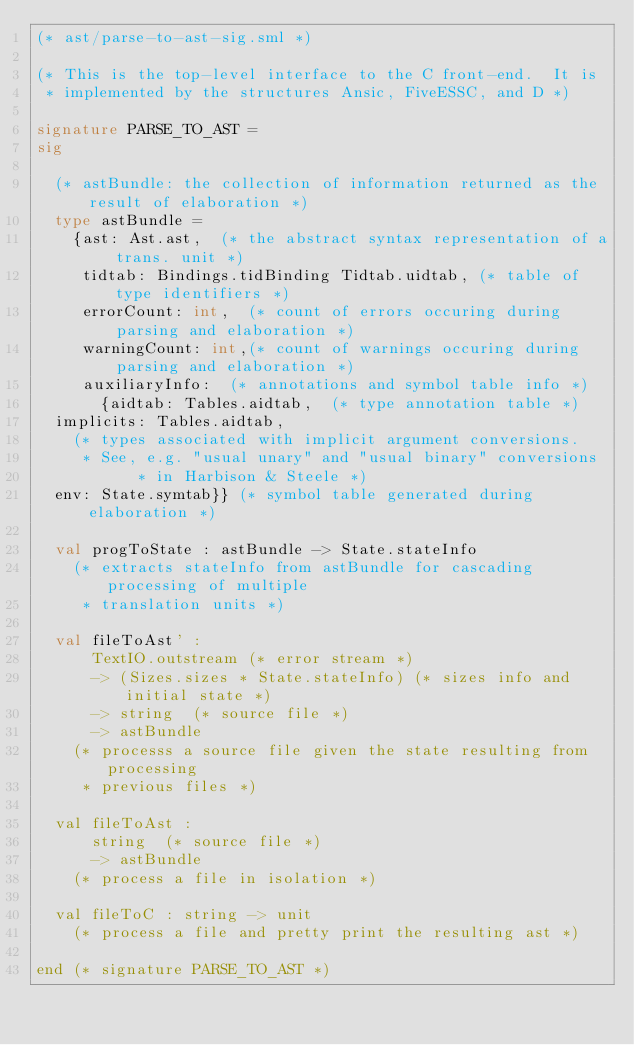Convert code to text. <code><loc_0><loc_0><loc_500><loc_500><_SML_>(* ast/parse-to-ast-sig.sml *)

(* This is the top-level interface to the C front-end.  It is 
 * implemented by the structures Ansic, FiveESSC, and D *)

signature PARSE_TO_AST =
sig

  (* astBundle: the collection of information returned as the result of elaboration *)
  type astBundle =
    {ast: Ast.ast,  (* the abstract syntax representation of a trans. unit *)
     tidtab: Bindings.tidBinding Tidtab.uidtab, (* table of type identifiers *)
     errorCount: int,  (* count of errors occuring during parsing and elaboration *)
     warningCount: int,(* count of warnings occuring during parsing and elaboration *)
     auxiliaryInfo:  (* annotations and symbol table info *)
       {aidtab: Tables.aidtab,  (* type annotation table *)
	implicits: Tables.aidtab,
	  (* types associated with implicit argument conversions.
	   * See, e.g. "usual unary" and "usual binary" conversions
           * in Harbison & Steele *)
	env: State.symtab}} (* symbol table generated during elaboration *)

  val progToState : astBundle -> State.stateInfo
    (* extracts stateInfo from astBundle for cascading processing of multiple
     * translation units *)

  val fileToAst' : 
      TextIO.outstream (* error stream *)
      -> (Sizes.sizes * State.stateInfo) (* sizes info and initial state *)
      -> string  (* source file *)
      -> astBundle
    (* processs a source file given the state resulting from processing
     * previous files *)

  val fileToAst :
      string  (* source file *)
      -> astBundle
    (* process a file in isolation *)

  val fileToC : string -> unit
    (* process a file and pretty print the resulting ast *)

end (* signature PARSE_TO_AST *)
</code> 